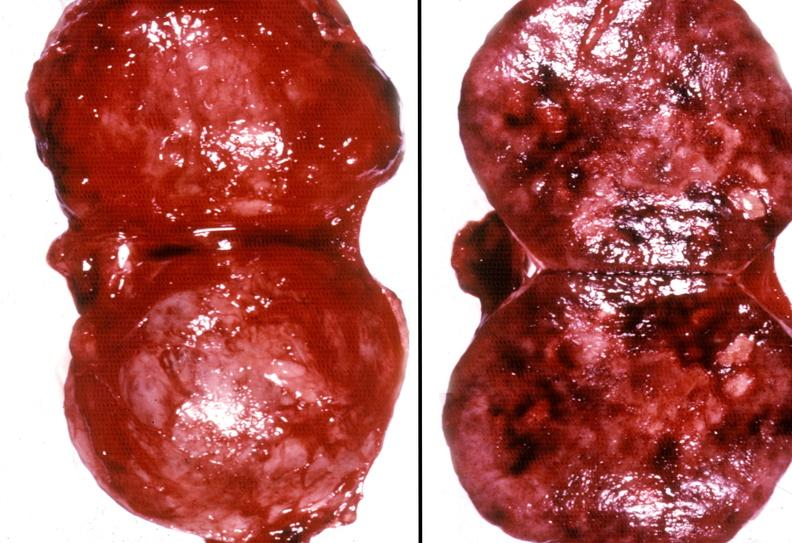where does this belong to?
Answer the question using a single word or phrase. Endocrine system 